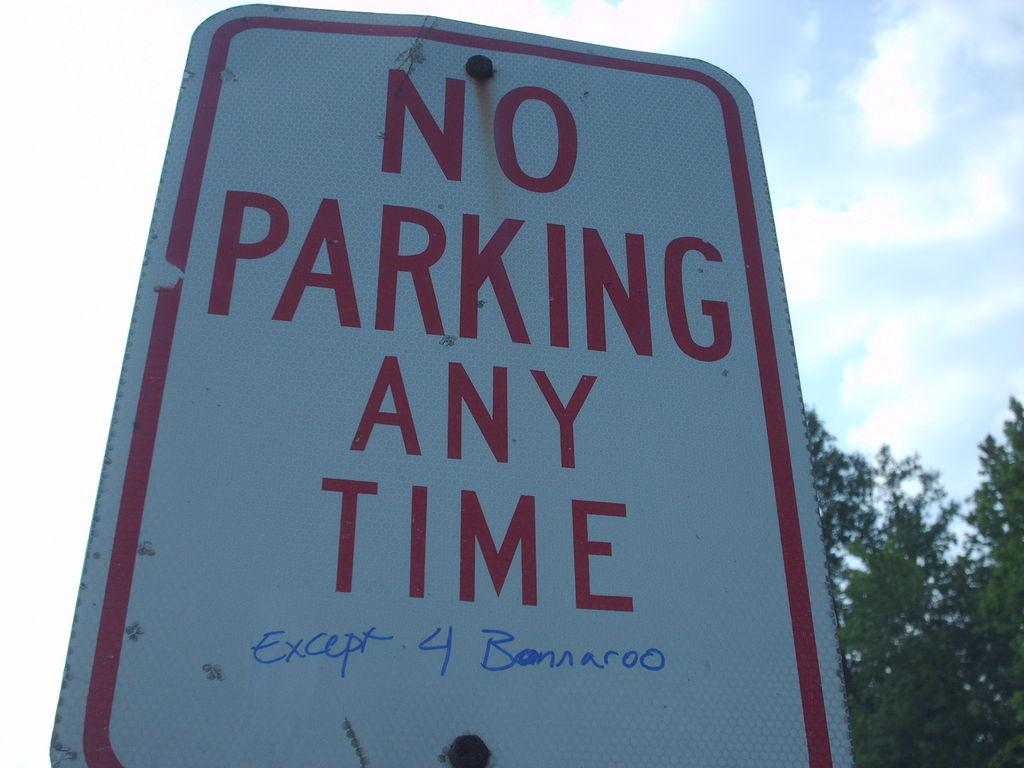<image>
Write a terse but informative summary of the picture. A red and white street sign prohibiting parking any time. 